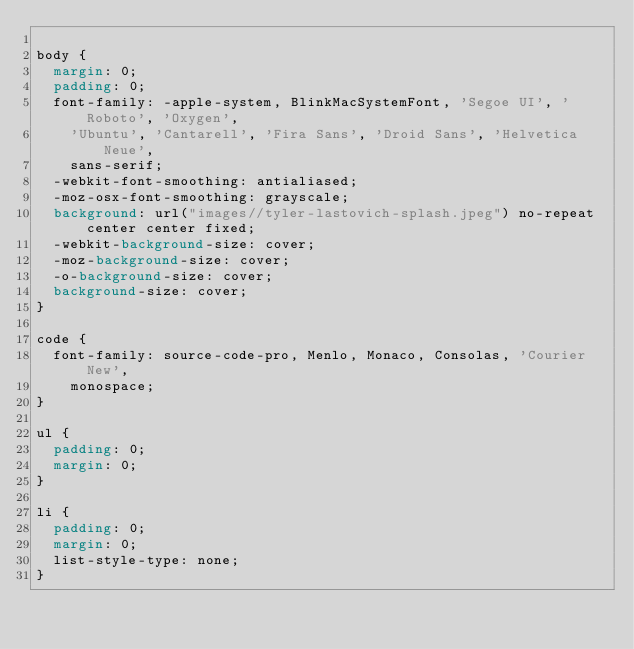<code> <loc_0><loc_0><loc_500><loc_500><_CSS_>
body {
  margin: 0;
  padding: 0;
  font-family: -apple-system, BlinkMacSystemFont, 'Segoe UI', 'Roboto', 'Oxygen',
    'Ubuntu', 'Cantarell', 'Fira Sans', 'Droid Sans', 'Helvetica Neue',
    sans-serif;
  -webkit-font-smoothing: antialiased;
  -moz-osx-font-smoothing: grayscale;
  background: url("images//tyler-lastovich-splash.jpeg") no-repeat center center fixed;
  -webkit-background-size: cover;
  -moz-background-size: cover;
  -o-background-size: cover;
  background-size: cover;
}

code {
  font-family: source-code-pro, Menlo, Monaco, Consolas, 'Courier New',
    monospace;
}

ul {
  padding: 0;
  margin: 0;
}

li {
  padding: 0;
  margin: 0;
  list-style-type: none;
}
</code> 